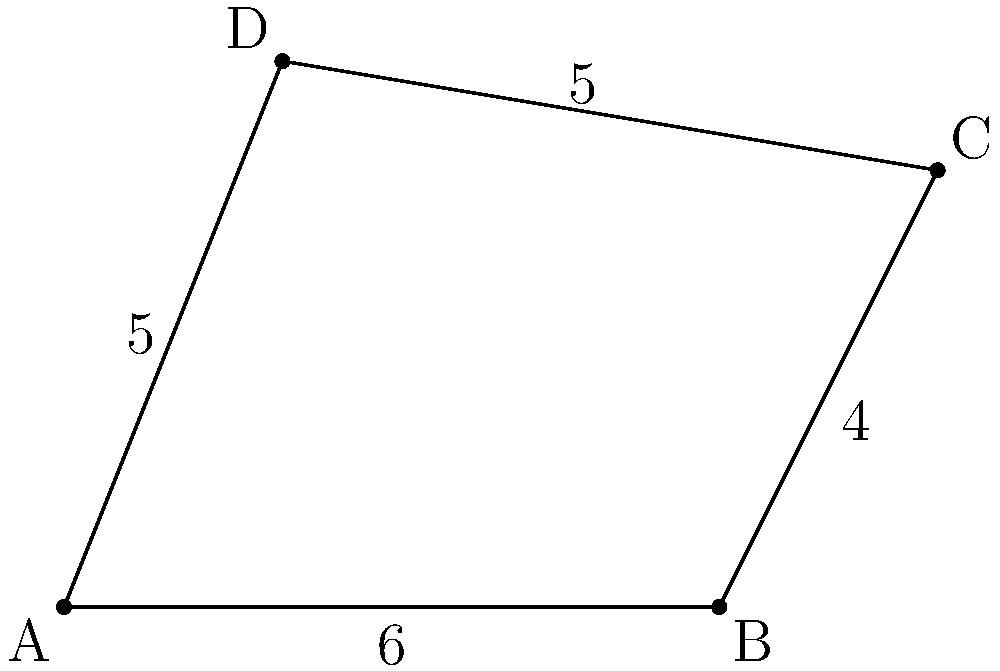As the neighborhood association president, you're overseeing a community garden project. The garden plot has an irregular shape, represented by the coordinates of its corners: A(0,0), B(6,0), C(8,4), and D(2,5). To ensure privacy and security, you need to install fencing around the entire perimeter. What is the total length of fencing required for this oddly-shaped lot? To find the total length of fencing needed, we need to calculate the perimeter of the polygon formed by points A, B, C, and D. We'll do this by finding the length of each side and then summing them up.

1. Length of AB:
   $AB = \sqrt{(6-0)^2 + (0-0)^2} = 6$

2. Length of BC:
   $BC = \sqrt{(8-6)^2 + (4-0)^2} = \sqrt{4 + 16} = \sqrt{20} = 2\sqrt{5}$

3. Length of CD:
   $CD = \sqrt{(2-8)^2 + (5-4)^2} = \sqrt{36 + 1} = \sqrt{37}$

4. Length of DA:
   $DA = \sqrt{(0-2)^2 + (0-5)^2} = \sqrt{4 + 25} = \sqrt{29}$

5. Total perimeter:
   $Perimeter = AB + BC + CD + DA$
   $= 6 + 2\sqrt{5} + \sqrt{37} + \sqrt{29}$

This expression cannot be simplified further without approximation.
Answer: $6 + 2\sqrt{5} + \sqrt{37} + \sqrt{29}$ units 